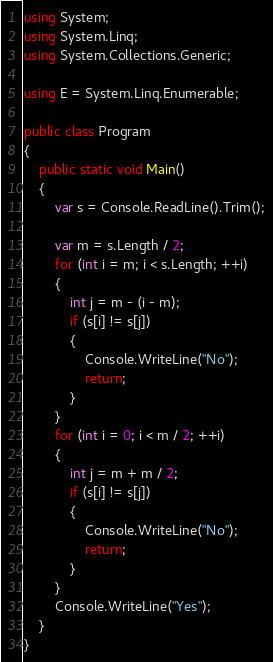<code> <loc_0><loc_0><loc_500><loc_500><_C#_>using System;
using System.Linq;
using System.Collections.Generic;

using E = System.Linq.Enumerable;

public class Program
{
    public static void Main()
    {
        var s = Console.ReadLine().Trim();

        var m = s.Length / 2;
        for (int i = m; i < s.Length; ++i)
        {
            int j = m - (i - m);
            if (s[i] != s[j])
            {
                Console.WriteLine("No");
                return;
            }
        }
        for (int i = 0; i < m / 2; ++i)
        {
            int j = m + m / 2;
            if (s[i] != s[j])
            {
                Console.WriteLine("No");
                return;
            }
        }
        Console.WriteLine("Yes");
    }
}
</code> 